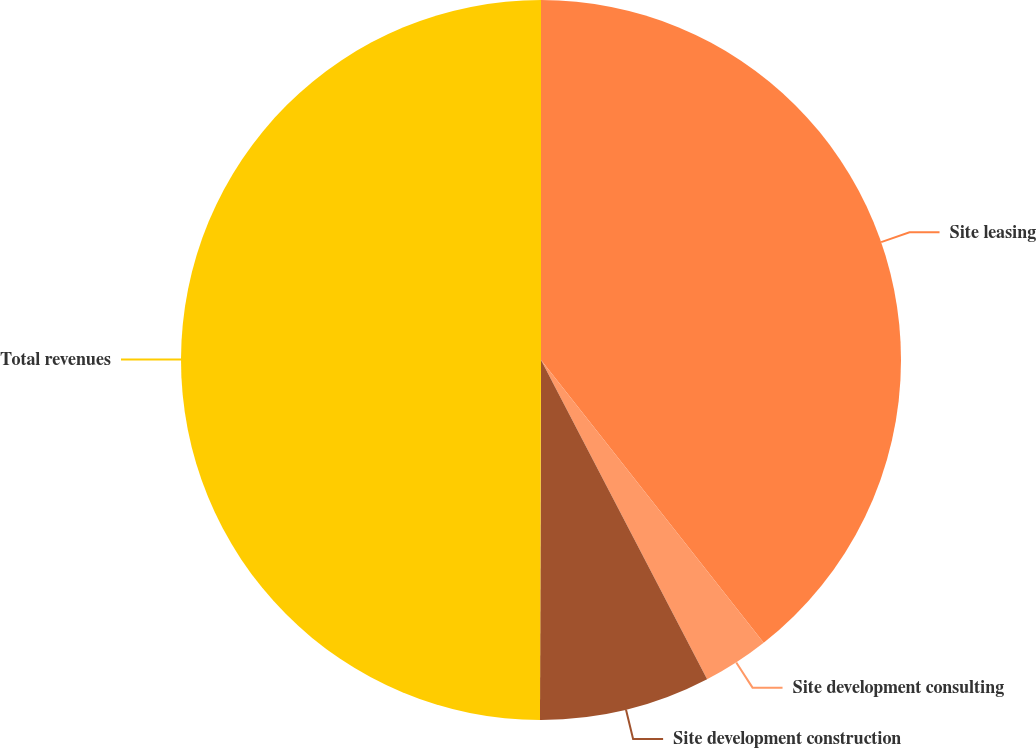Convert chart to OTSL. <chart><loc_0><loc_0><loc_500><loc_500><pie_chart><fcel>Site leasing<fcel>Site development consulting<fcel>Site development construction<fcel>Total revenues<nl><fcel>39.39%<fcel>2.98%<fcel>7.68%<fcel>49.96%<nl></chart> 